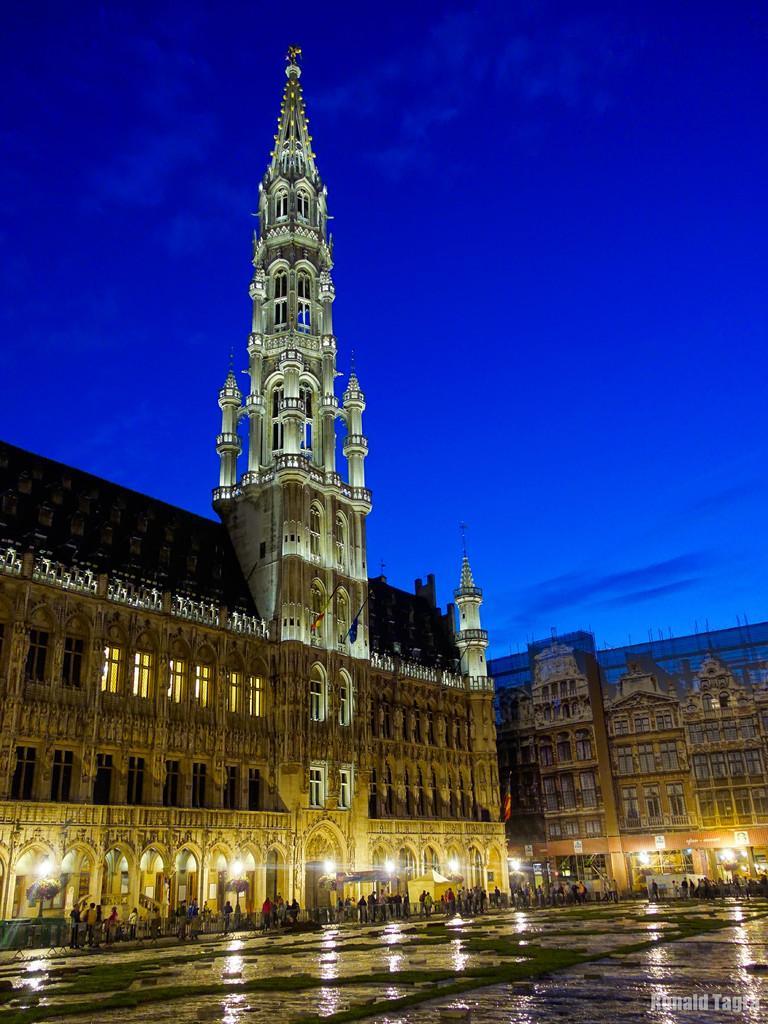Please provide a concise description of this image. In this image we can see a building with windows, roof and lights. We can also see some people walking on the pathway. On the backside we can see the sky which looks cloudy. 